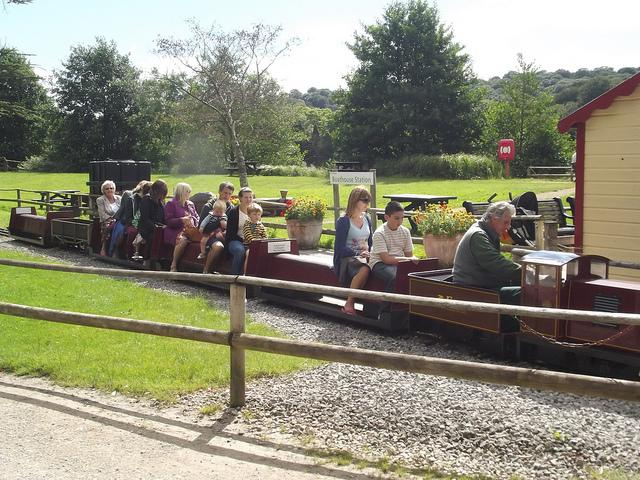What type people ride on this train?

Choices:
A) elderly only
B) salesmen
C) mall workers
D) tourists tourists 